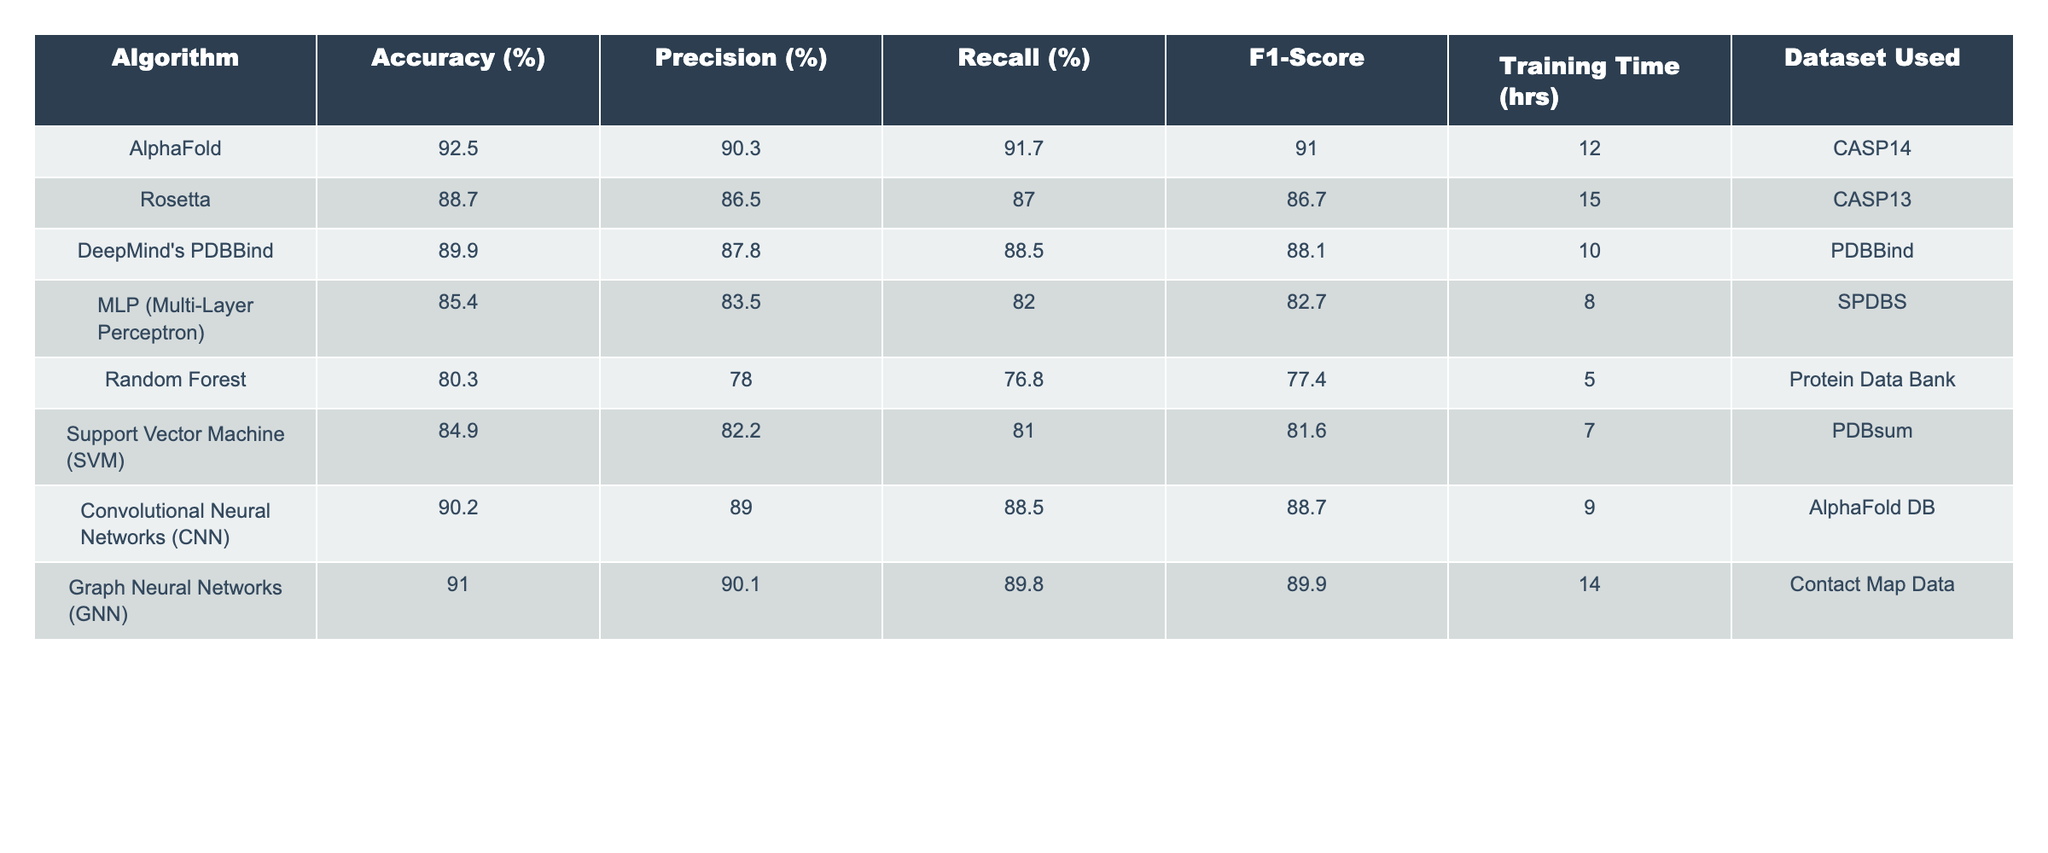What is the accuracy of AlphaFold? The table shows the accuracy (%) for AlphaFold in the corresponding row, which is listed as 92.5%.
Answer: 92.5% Which algorithm has the highest F1-Score? By comparing the F1-Scores in the table, AlphaFold has the highest F1-Score of 91.0, which is greater than any other algorithm listed.
Answer: AlphaFold What is the average training time of the algorithms listed in the table? To find the average training time, sum the training times: 12 + 15 + 10 + 8 + 5 + 7 + 9 + 14 = 80 hours. Then divide by the number of algorithms (8): 80 / 8 = 10 hours.
Answer: 10 hours Is the Recall percentage for CNN greater than 85%? The Recall percentage for CNN is listed as 88.5%, which is indeed greater than 85%.
Answer: Yes What is the difference in accuracy between Rosetta and MLP? The accuracy for Rosetta is 88.7%, and for MLP it is 85.4%. The difference is calculated as: 88.7 - 85.4 = 3.3%.
Answer: 3.3% Which two algorithms have the closest precision percentages? Looking at the precision percentages: Rosetta (86.5%) and DeepMind's PDBBind (87.8%) have the closest values when considering the gap, which is 1.3%.
Answer: Rosetta and DeepMind's PDBBind What is the total number of algorithms with an accuracy over 90%? The algorithms with an accuracy over 90% are AlphaFold (92.5%), CNN (90.2%), and GNN (91.0%), totaling three algorithms.
Answer: 3 algorithms Which algorithm has the lowest precision percentage, and what is its value? The algorithm with the lowest precision percentage is Random Forest, listed as 78.0%.
Answer: Random Forest, 78.0% If we set a threshold of 88% accuracy, how many algorithms exceed this threshold? The algorithms that exceed 88% accuracy are AlphaFold, DeepMind's PDBBind, CNN, and GNN, meaning a total of four algorithms exceed the threshold.
Answer: 4 algorithms Which algorithm used the smallest amount of training time, and what was it? The training time for Random Forest is the smallest at 5 hours as seen in the table.
Answer: Random Forest, 5 hours 